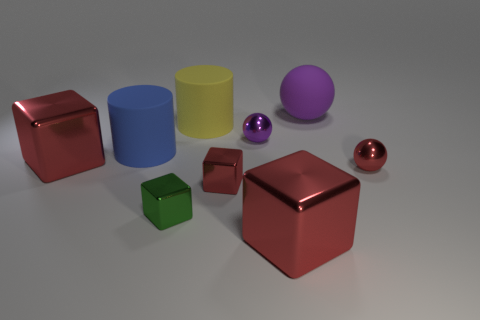There is a cylinder that is in front of the purple metal thing; what material is it?
Your answer should be compact. Rubber. There is a cylinder that is the same material as the yellow thing; what is its size?
Make the answer very short. Large. How many purple rubber things are the same shape as the big yellow thing?
Provide a succinct answer. 0. There is a tiny purple metallic thing; is it the same shape as the large red thing on the right side of the tiny green thing?
Your answer should be very brief. No. The shiny object that is the same color as the large ball is what shape?
Keep it short and to the point. Sphere. Is there a purple thing that has the same material as the green thing?
Offer a very short reply. Yes. Is there any other thing that has the same material as the big sphere?
Offer a very short reply. Yes. What material is the big red object that is to the right of the red block that is behind the tiny red shiny ball?
Make the answer very short. Metal. There is a purple metallic thing to the left of the large red shiny cube that is in front of the thing on the right side of the large purple sphere; what size is it?
Provide a short and direct response. Small. How many other things are there of the same shape as the small purple object?
Make the answer very short. 2. 